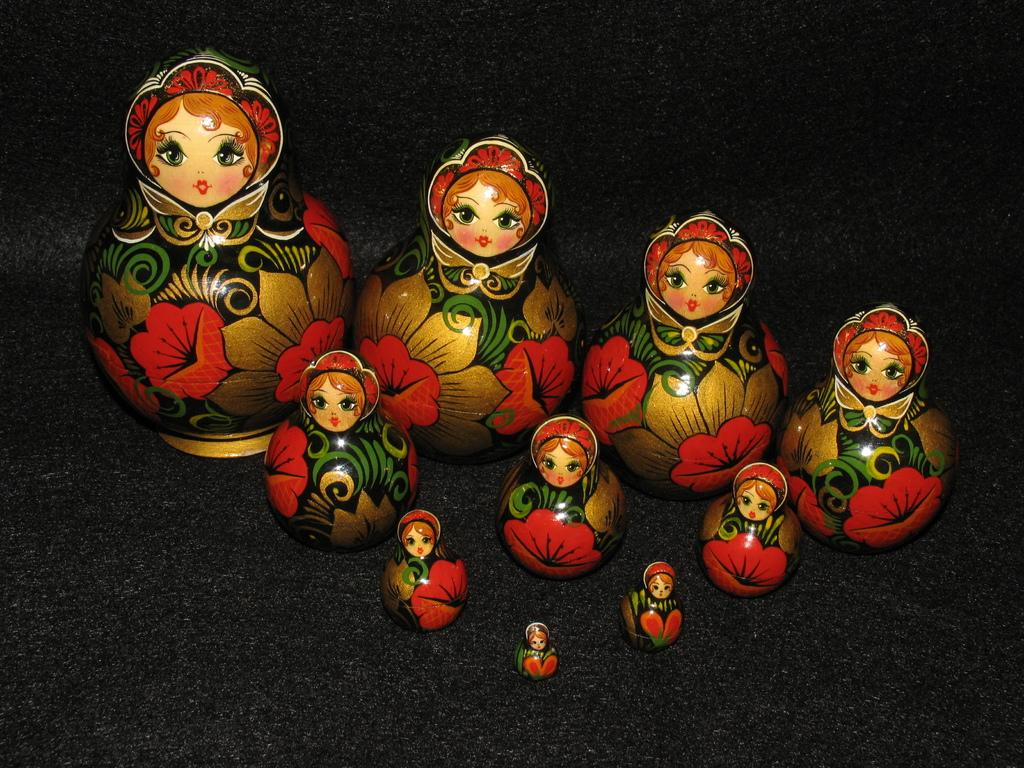What type of bowls are visible in the image? There are ceramic bowls in the image. Where are the ceramic bowls located? The ceramic bowls are placed on a black surface. What type of joke is being told by the ceramic bowls in the image? There is no joke being told by the ceramic bowls in the image, as they are inanimate objects and cannot speak or tell jokes. 